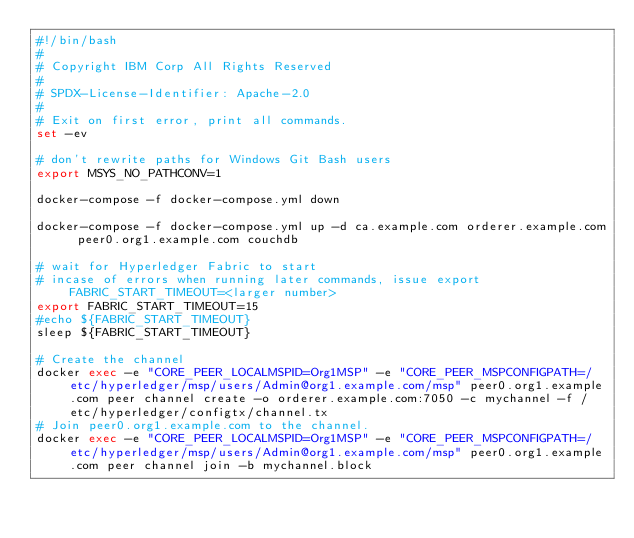<code> <loc_0><loc_0><loc_500><loc_500><_Bash_>#!/bin/bash
#
# Copyright IBM Corp All Rights Reserved
#
# SPDX-License-Identifier: Apache-2.0
#
# Exit on first error, print all commands.
set -ev

# don't rewrite paths for Windows Git Bash users
export MSYS_NO_PATHCONV=1

docker-compose -f docker-compose.yml down

docker-compose -f docker-compose.yml up -d ca.example.com orderer.example.com peer0.org1.example.com couchdb

# wait for Hyperledger Fabric to start
# incase of errors when running later commands, issue export FABRIC_START_TIMEOUT=<larger number>
export FABRIC_START_TIMEOUT=15
#echo ${FABRIC_START_TIMEOUT}
sleep ${FABRIC_START_TIMEOUT}

# Create the channel
docker exec -e "CORE_PEER_LOCALMSPID=Org1MSP" -e "CORE_PEER_MSPCONFIGPATH=/etc/hyperledger/msp/users/Admin@org1.example.com/msp" peer0.org1.example.com peer channel create -o orderer.example.com:7050 -c mychannel -f /etc/hyperledger/configtx/channel.tx
# Join peer0.org1.example.com to the channel.
docker exec -e "CORE_PEER_LOCALMSPID=Org1MSP" -e "CORE_PEER_MSPCONFIGPATH=/etc/hyperledger/msp/users/Admin@org1.example.com/msp" peer0.org1.example.com peer channel join -b mychannel.block
</code> 